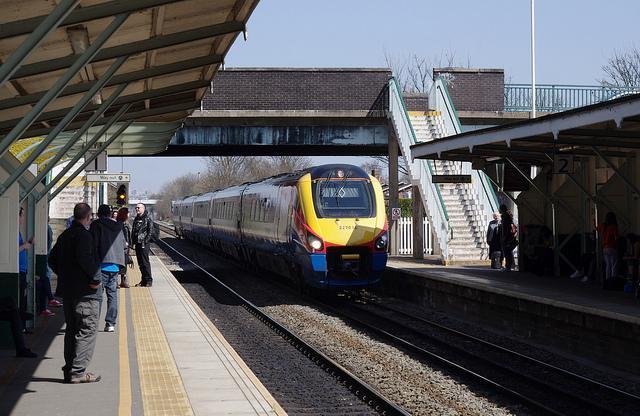How many colors are on the train?
Give a very brief answer. 3. How many people are waiting for the train?
Give a very brief answer. 4. How many people are in the photo?
Give a very brief answer. 3. 